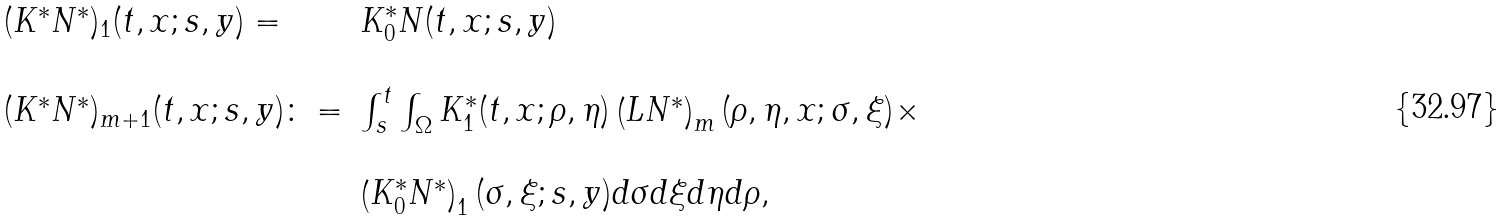<formula> <loc_0><loc_0><loc_500><loc_500>\begin{array} { l l } ( K ^ { * } N ^ { * } ) _ { 1 } ( t , x ; s , y ) = & K ^ { * } _ { 0 } N ( t , x ; s , y ) \\ \\ ( K ^ { * } N ^ { * } ) _ { m + 1 } ( t , x ; s , y ) \colon = & \int _ { s } ^ { t } \int _ { \Omega } K ^ { * } _ { 1 } ( t , x ; \rho , \eta ) \left ( L N ^ { * } \right ) _ { m } ( \rho , \eta , x ; \sigma , \xi ) \times \\ \\ & \left ( K ^ { * } _ { 0 } N ^ { * } \right ) _ { 1 } ( \sigma , \xi ; s , y ) d \sigma d \xi d \eta d \rho , \end{array}</formula> 